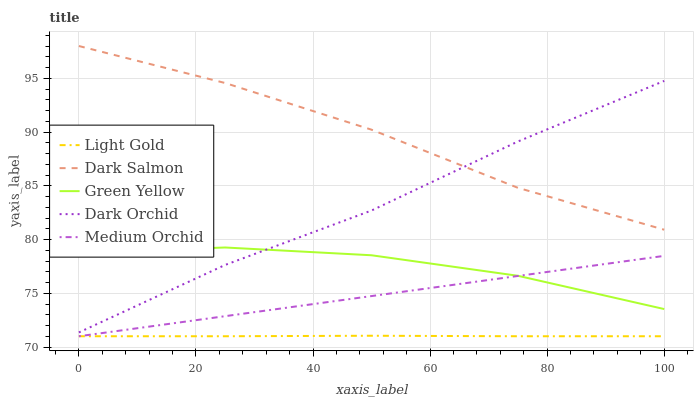Does Light Gold have the minimum area under the curve?
Answer yes or no. Yes. Does Dark Salmon have the maximum area under the curve?
Answer yes or no. Yes. Does Green Yellow have the minimum area under the curve?
Answer yes or no. No. Does Green Yellow have the maximum area under the curve?
Answer yes or no. No. Is Medium Orchid the smoothest?
Answer yes or no. Yes. Is Green Yellow the roughest?
Answer yes or no. Yes. Is Light Gold the smoothest?
Answer yes or no. No. Is Light Gold the roughest?
Answer yes or no. No. Does Green Yellow have the lowest value?
Answer yes or no. No. Does Green Yellow have the highest value?
Answer yes or no. No. Is Light Gold less than Dark Orchid?
Answer yes or no. Yes. Is Dark Orchid greater than Medium Orchid?
Answer yes or no. Yes. Does Light Gold intersect Dark Orchid?
Answer yes or no. No. 